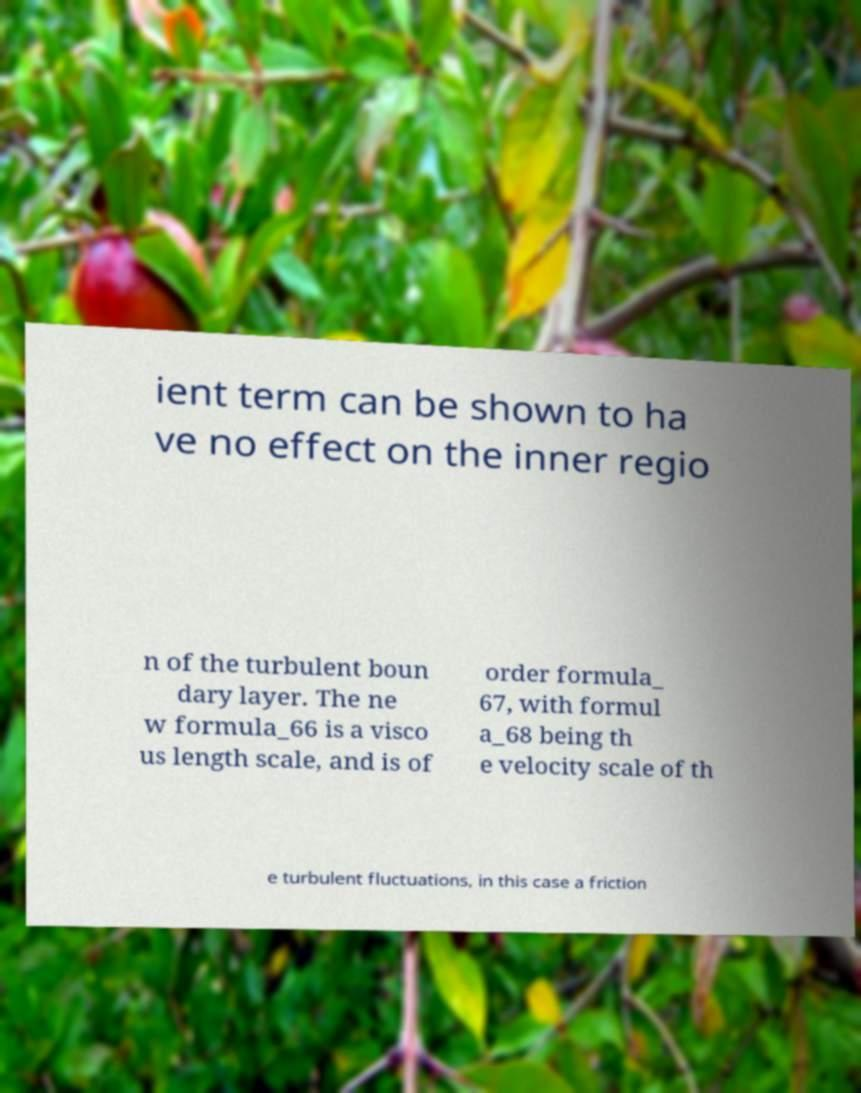There's text embedded in this image that I need extracted. Can you transcribe it verbatim? ient term can be shown to ha ve no effect on the inner regio n of the turbulent boun dary layer. The ne w formula_66 is a visco us length scale, and is of order formula_ 67, with formul a_68 being th e velocity scale of th e turbulent fluctuations, in this case a friction 